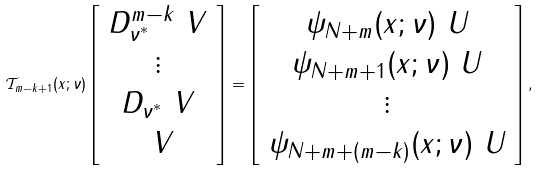Convert formula to latex. <formula><loc_0><loc_0><loc_500><loc_500>\mathcal { T } _ { m - k + 1 } ( x ; \nu ) \left [ \begin{array} { c } D _ { \nu ^ { * } } ^ { m - k } \ V \\ \vdots \\ D _ { \nu ^ { * } } \ V \\ \ V \\ \end{array} \right ] = \left [ \begin{array} { c } \psi _ { N + m } ( x ; \nu ) \ U \\ \psi _ { N + m + 1 } ( x ; \nu ) \ U \\ \vdots \\ \psi _ { N + m + ( m - k ) } ( x ; \nu ) \ U \\ \end{array} \right ] ,</formula> 